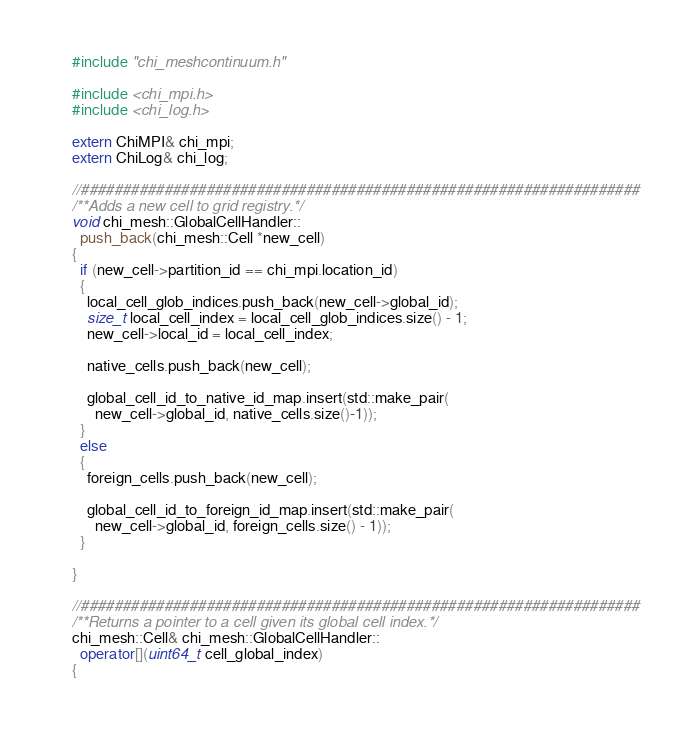<code> <loc_0><loc_0><loc_500><loc_500><_C++_>#include "chi_meshcontinuum.h"

#include <chi_mpi.h>
#include <chi_log.h>

extern ChiMPI& chi_mpi;
extern ChiLog& chi_log;

//###################################################################
/**Adds a new cell to grid registry.*/
void chi_mesh::GlobalCellHandler::
  push_back(chi_mesh::Cell *new_cell)
{
  if (new_cell->partition_id == chi_mpi.location_id)
  {
    local_cell_glob_indices.push_back(new_cell->global_id);
    size_t local_cell_index = local_cell_glob_indices.size() - 1;
    new_cell->local_id = local_cell_index;

    native_cells.push_back(new_cell);

    global_cell_id_to_native_id_map.insert(std::make_pair(
      new_cell->global_id, native_cells.size()-1));
  }
  else
  {
    foreign_cells.push_back(new_cell);

    global_cell_id_to_foreign_id_map.insert(std::make_pair(
      new_cell->global_id, foreign_cells.size() - 1));
  }

}

//###################################################################
/**Returns a pointer to a cell given its global cell index.*/
chi_mesh::Cell& chi_mesh::GlobalCellHandler::
  operator[](uint64_t cell_global_index)
{</code> 